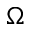Convert formula to latex. <formula><loc_0><loc_0><loc_500><loc_500>\Omega</formula> 